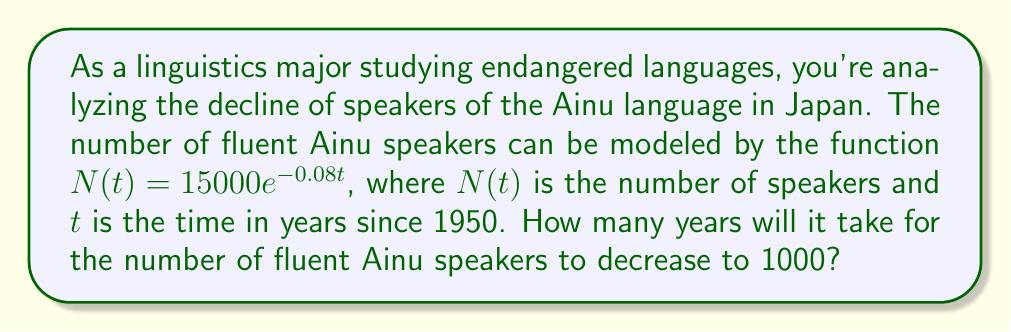Give your solution to this math problem. To solve this problem, we need to use the given exponential function and solve for $t$ when $N(t) = 1000$. Let's approach this step-by-step:

1) We start with the equation:
   $N(t) = 15000e^{-0.08t}$

2) We want to find $t$ when $N(t) = 1000$, so we set up the equation:
   $1000 = 15000e^{-0.08t}$

3) Divide both sides by 15000:
   $\frac{1000}{15000} = e^{-0.08t}$

4) Simplify:
   $\frac{1}{15} = e^{-0.08t}$

5) Take the natural logarithm of both sides:
   $\ln(\frac{1}{15}) = \ln(e^{-0.08t})$

6) Simplify the right side using the property of logarithms:
   $\ln(\frac{1}{15}) = -0.08t$

7) Solve for $t$:
   $t = \frac{\ln(\frac{1}{15})}{-0.08}$

8) Calculate:
   $t = \frac{\ln(0.0666...)}{-0.08} \approx 33.56$

9) Round to the nearest year:
   $t \approx 34$ years

Therefore, it will take approximately 34 years from 1950 for the number of fluent Ainu speakers to decrease to 1000.
Answer: 34 years 